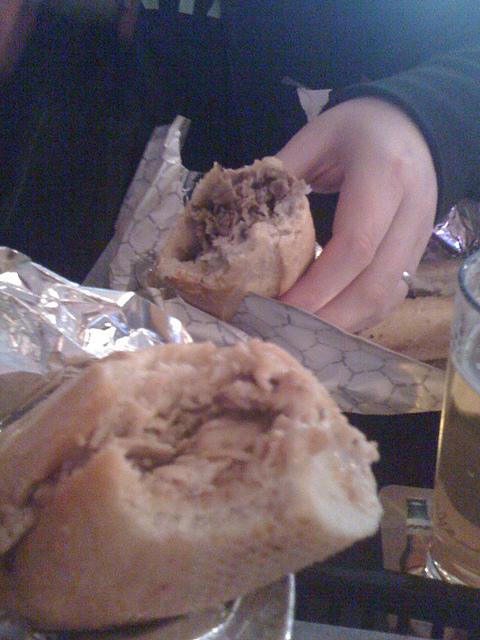Have these sandwiches been bitten into?
Keep it brief. Yes. Is this person likely married?
Be succinct. Yes. How many sandwiches do you see?
Be succinct. 2. 